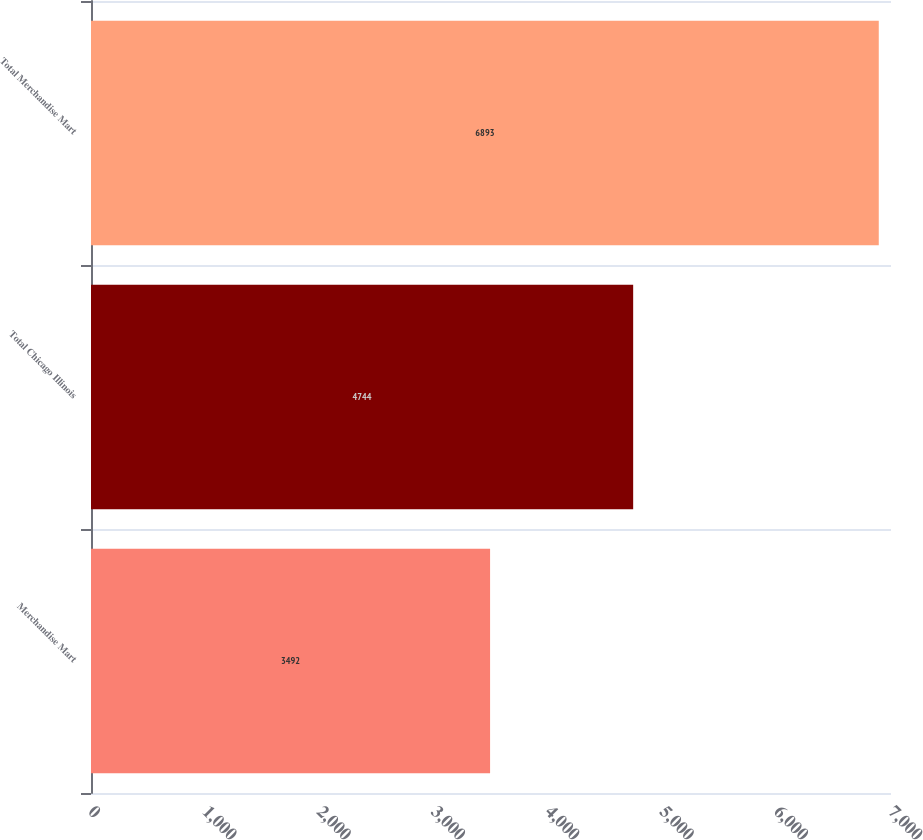Convert chart. <chart><loc_0><loc_0><loc_500><loc_500><bar_chart><fcel>Merchandise Mart<fcel>Total Chicago Illinois<fcel>Total Merchandise Mart<nl><fcel>3492<fcel>4744<fcel>6893<nl></chart> 